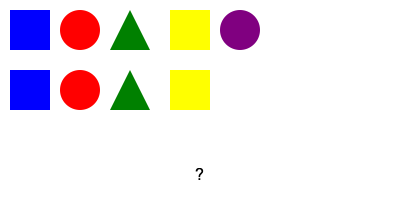Based on the pattern of business role symbols, which shape and color should replace the question mark to complete the sequence? To solve this pattern recognition test, let's analyze the sequence of symbols:

1. The pattern consists of two rows with four symbols each.
2. The first row shows: blue square, red circle, green triangle, yellow square, purple circle.
3. The second row begins with: blue square, red circle, green triangle, yellow square.
4. We can observe that the first four symbols in the second row exactly match the first four symbols in the first row.
5. Following this pattern, the next symbol in the sequence should match the fifth symbol in the first row.
6. The fifth symbol in the first row is a purple circle.

Therefore, to maintain the pattern and complete the sequence, the symbol that should replace the question mark is a purple circle.

This test demonstrates the importance of recognizing patterns and logical sequences, which are crucial skills in business decision-making and strategic planning. It aligns with the traditionalist business owner's perspective by focusing on merit-based problem-solving rather than arbitrary quotas or predetermined outcomes.
Answer: Purple circle 